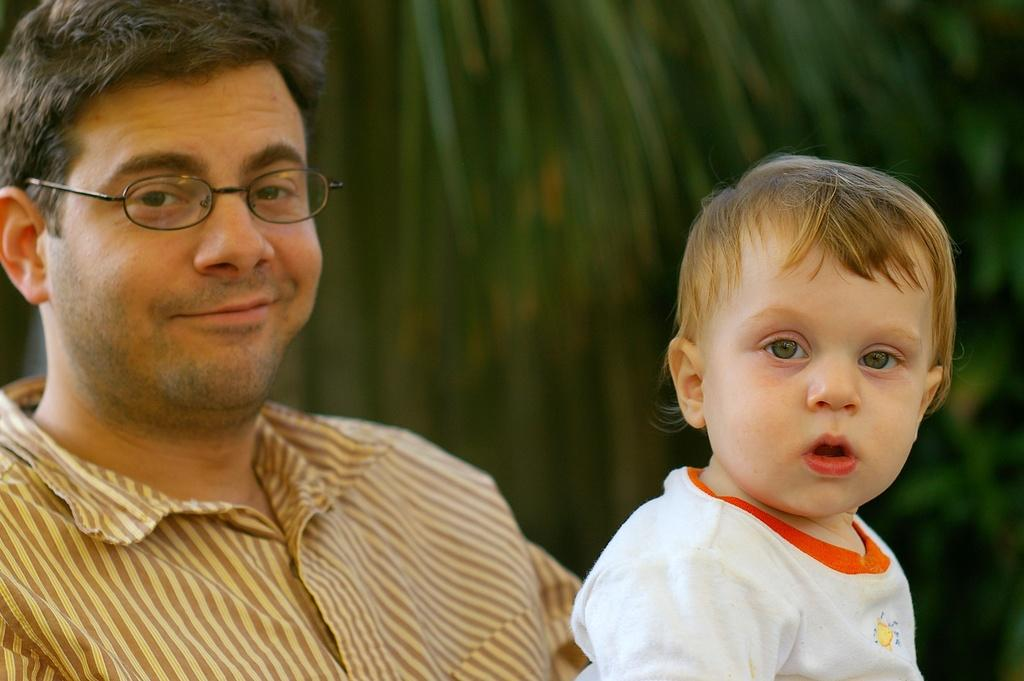Who is present in the image? There is a man in the image. What is the man doing in the image? The man is smiling in the image. Who is with the man in the image? There is a kid beside the man in the image. How is the background of the man and the kid depicted in the image? The background of the man and the kid is blurred in the image. What type of metal is the reward being given to the man in the image? There is no reward or metal present in the image. 